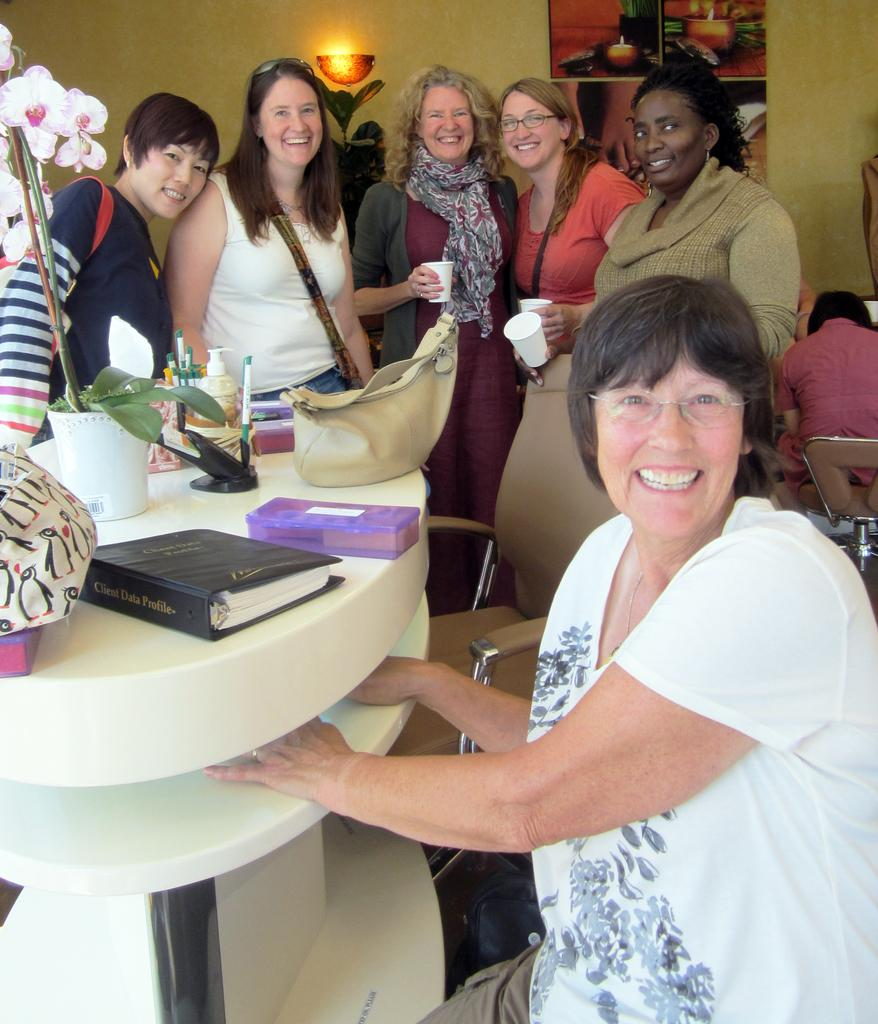<image>
Share a concise interpretation of the image provided. a lady sitting next to a data profile book on her right 